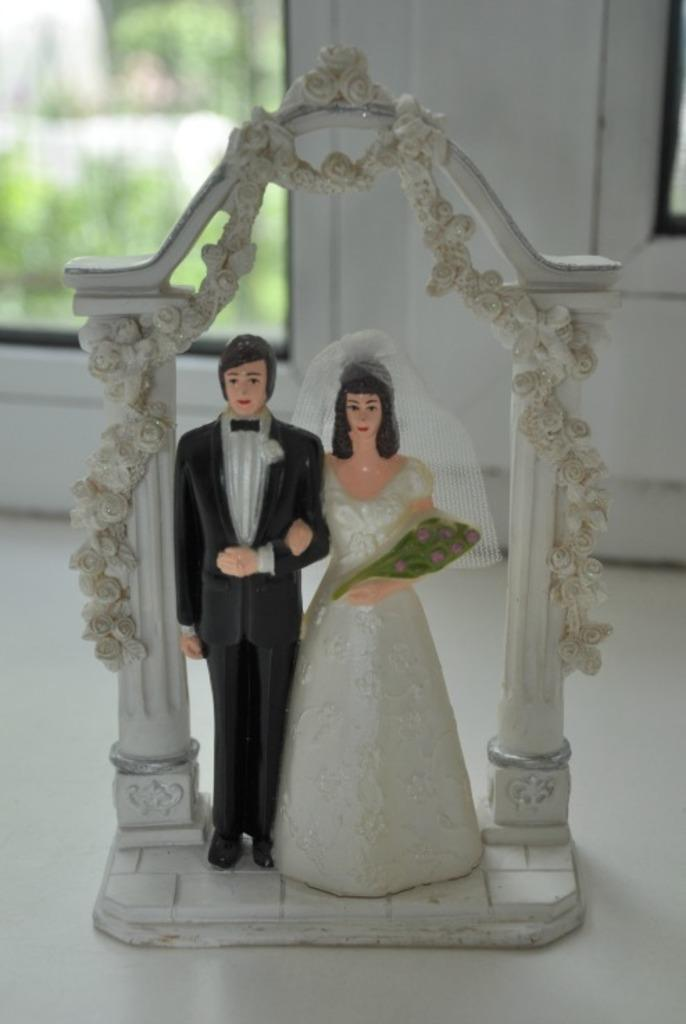What is the main subject in the image? There is a statue in the image. Where is the statue located? The statue is on the floor. What can be seen in the background of the image? There is a window in the background of the image. What type of meal is being prepared in the image? There is no meal being prepared in the image; it features a statue on the floor with a window in the background. Can you see any salt on the statue in the image? There is no salt visible on the statue in the image. 